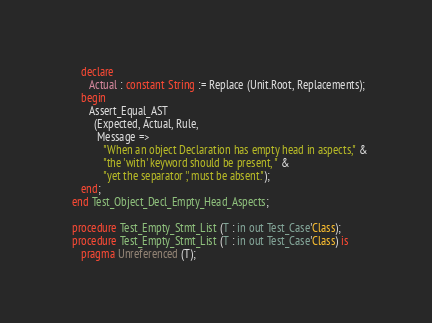Convert code to text. <code><loc_0><loc_0><loc_500><loc_500><_Ada_>      declare
         Actual : constant String := Replace (Unit.Root, Replacements);
      begin
         Assert_Equal_AST
           (Expected, Actual, Rule,
            Message =>
              "When an object Declaration has empty head in aspects," &
              "the 'with' keyword should be present, " &
              "yet the separator ',' must be absent.");
      end;
   end Test_Object_Decl_Empty_Head_Aspects;

   procedure Test_Empty_Stmt_List (T : in out Test_Case'Class);
   procedure Test_Empty_Stmt_List (T : in out Test_Case'Class) is
      pragma Unreferenced (T);
</code> 